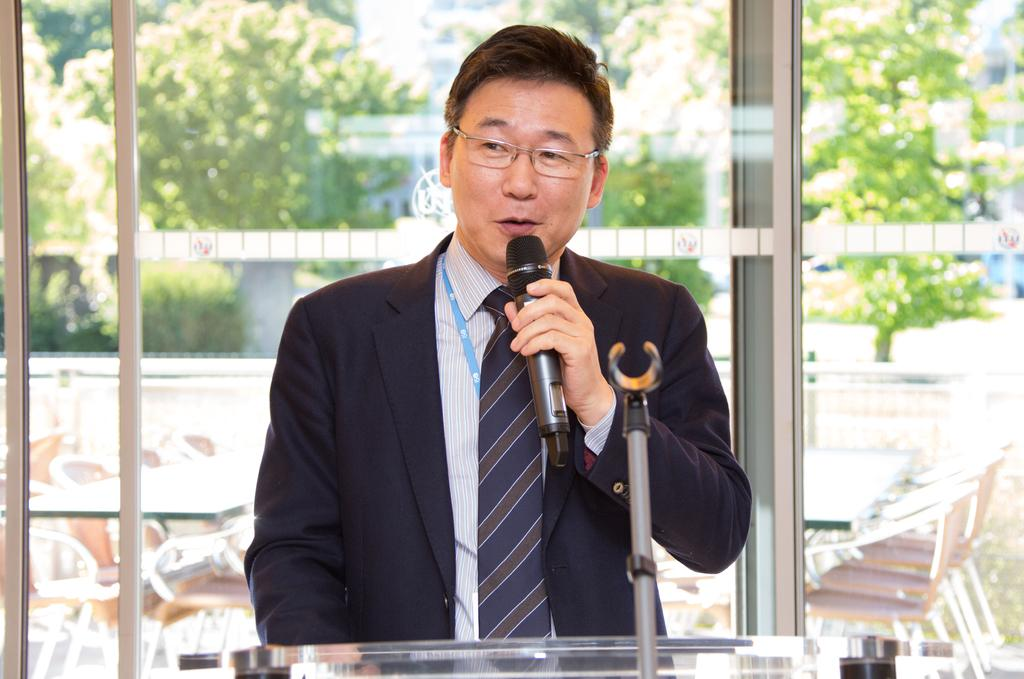What is the appearance of the man in the image? The man in the image is wearing a black suit and spectacles. What is the man holding in his left hand? The man is holding a mic in his left hand. What can be seen through the glass wall in the image? There are plants outside the glass wall. What is the purpose of the glass wall in the image? The glass wall serves as a barrier between the indoor and outdoor environments. Where is the playground located in the image? There is no playground present in the image. What type of butter is being used in the image? There is no butter present in the image. 